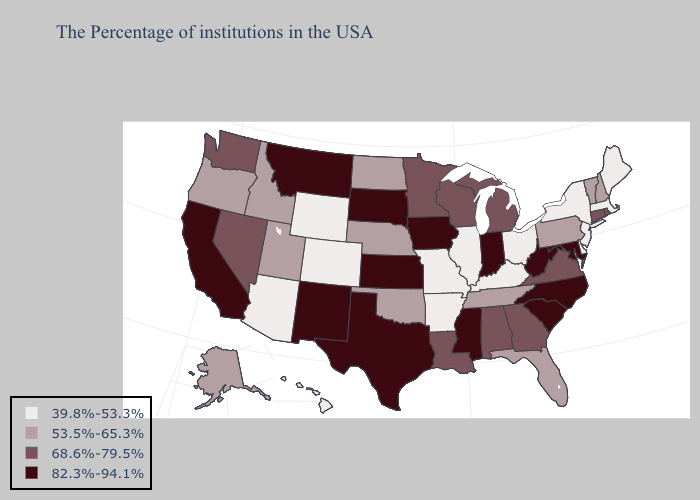What is the value of New Hampshire?
Give a very brief answer. 53.5%-65.3%. Name the states that have a value in the range 82.3%-94.1%?
Give a very brief answer. Maryland, North Carolina, South Carolina, West Virginia, Indiana, Mississippi, Iowa, Kansas, Texas, South Dakota, New Mexico, Montana, California. Does Nevada have the lowest value in the West?
Give a very brief answer. No. Name the states that have a value in the range 82.3%-94.1%?
Give a very brief answer. Maryland, North Carolina, South Carolina, West Virginia, Indiana, Mississippi, Iowa, Kansas, Texas, South Dakota, New Mexico, Montana, California. Name the states that have a value in the range 82.3%-94.1%?
Answer briefly. Maryland, North Carolina, South Carolina, West Virginia, Indiana, Mississippi, Iowa, Kansas, Texas, South Dakota, New Mexico, Montana, California. Which states hav the highest value in the MidWest?
Concise answer only. Indiana, Iowa, Kansas, South Dakota. Does Texas have the lowest value in the South?
Concise answer only. No. Does Nebraska have the same value as Idaho?
Concise answer only. Yes. What is the value of Maryland?
Concise answer only. 82.3%-94.1%. Does Oklahoma have the lowest value in the USA?
Answer briefly. No. What is the value of Ohio?
Be succinct. 39.8%-53.3%. Among the states that border New Mexico , does Arizona have the lowest value?
Short answer required. Yes. What is the value of Oregon?
Quick response, please. 53.5%-65.3%. What is the value of Arizona?
Be succinct. 39.8%-53.3%. What is the lowest value in the West?
Write a very short answer. 39.8%-53.3%. 